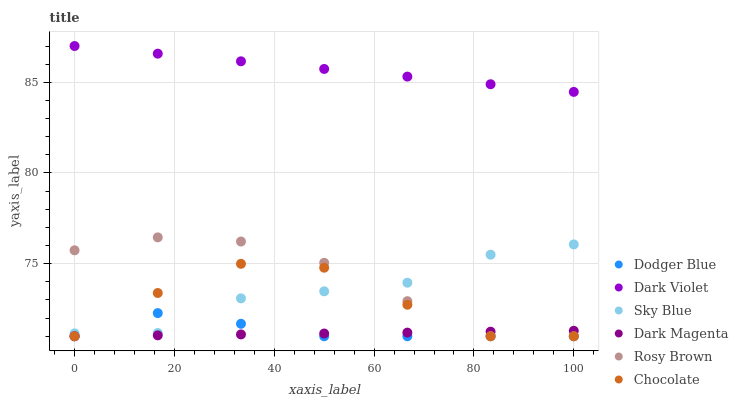Does Dark Magenta have the minimum area under the curve?
Answer yes or no. Yes. Does Dark Violet have the maximum area under the curve?
Answer yes or no. Yes. Does Rosy Brown have the minimum area under the curve?
Answer yes or no. No. Does Rosy Brown have the maximum area under the curve?
Answer yes or no. No. Is Dark Violet the smoothest?
Answer yes or no. Yes. Is Chocolate the roughest?
Answer yes or no. Yes. Is Rosy Brown the smoothest?
Answer yes or no. No. Is Rosy Brown the roughest?
Answer yes or no. No. Does Dark Magenta have the lowest value?
Answer yes or no. Yes. Does Dark Violet have the lowest value?
Answer yes or no. No. Does Dark Violet have the highest value?
Answer yes or no. Yes. Does Rosy Brown have the highest value?
Answer yes or no. No. Is Sky Blue less than Dark Violet?
Answer yes or no. Yes. Is Sky Blue greater than Dark Magenta?
Answer yes or no. Yes. Does Dark Magenta intersect Chocolate?
Answer yes or no. Yes. Is Dark Magenta less than Chocolate?
Answer yes or no. No. Is Dark Magenta greater than Chocolate?
Answer yes or no. No. Does Sky Blue intersect Dark Violet?
Answer yes or no. No. 